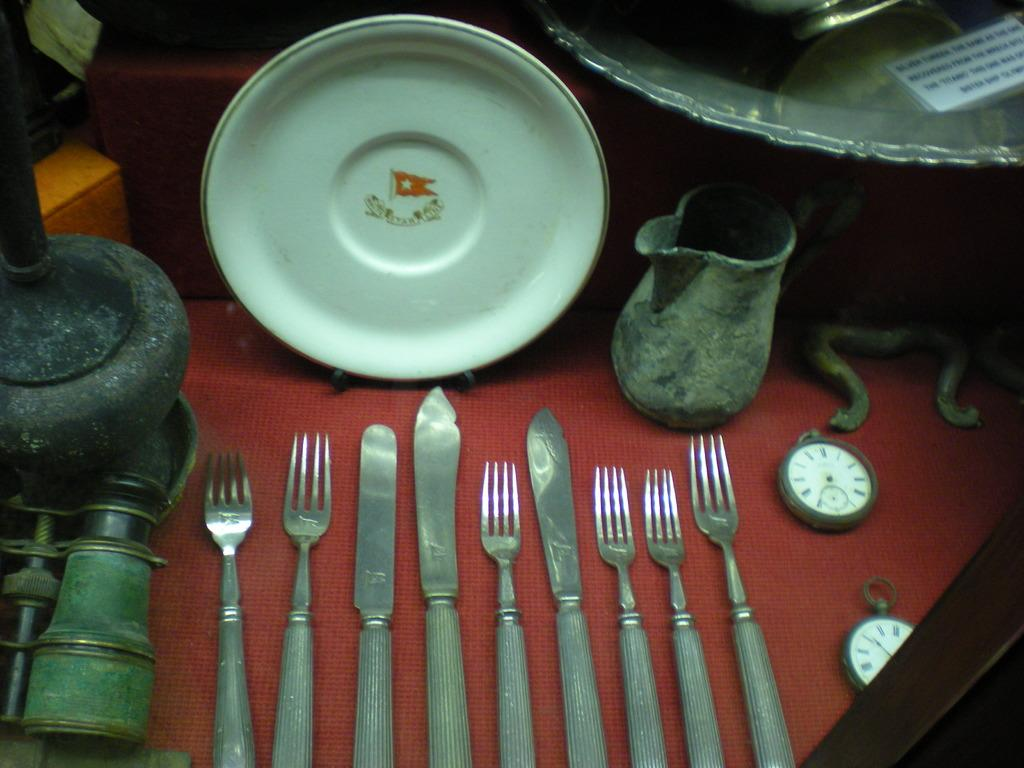What is one of the objects placed on the surface in the image? There is a plate in the image. What else can be seen on the surface in the image? There is a jug, clocks, forks, and knives present in the image. Can you describe the other objects present in the image? There are other objects present in the image, but their specific details are not mentioned in the provided facts. How many types of utensils are visible in the image? There are two types of utensils visible in the image: forks and knives. Can you tell me how many gallons of water are in the tank in the image? There is no tank or water present in the image; it only features a plate, a jug, clocks, forks, knives, and other unspecified objects placed on a surface. 